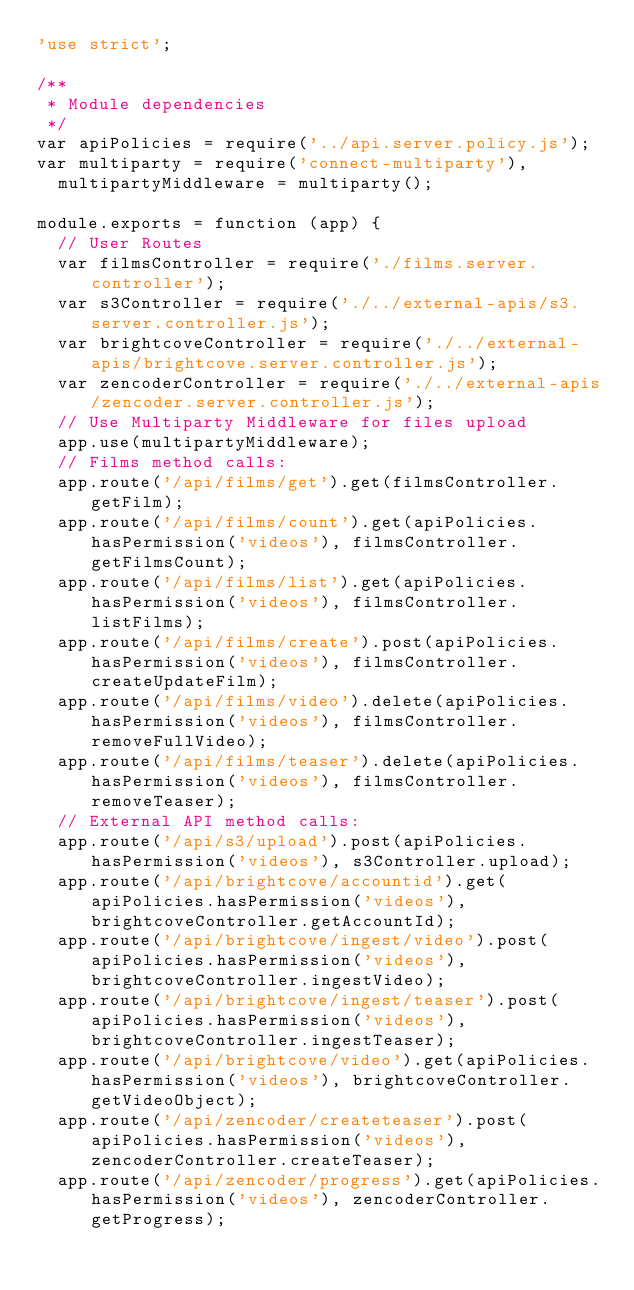<code> <loc_0><loc_0><loc_500><loc_500><_JavaScript_>'use strict';

/**
 * Module dependencies
 */
var apiPolicies = require('../api.server.policy.js');
var multiparty = require('connect-multiparty'),
  multipartyMiddleware = multiparty();

module.exports = function (app) {
  // User Routes
  var filmsController = require('./films.server.controller');
  var s3Controller = require('./../external-apis/s3.server.controller.js');
  var brightcoveController = require('./../external-apis/brightcove.server.controller.js');
  var zencoderController = require('./../external-apis/zencoder.server.controller.js');
  // Use Multiparty Middleware for files upload
  app.use(multipartyMiddleware);
  // Films method calls:
  app.route('/api/films/get').get(filmsController.getFilm);
  app.route('/api/films/count').get(apiPolicies.hasPermission('videos'), filmsController.getFilmsCount);
  app.route('/api/films/list').get(apiPolicies.hasPermission('videos'), filmsController.listFilms);
  app.route('/api/films/create').post(apiPolicies.hasPermission('videos'), filmsController.createUpdateFilm);
  app.route('/api/films/video').delete(apiPolicies.hasPermission('videos'), filmsController.removeFullVideo);
  app.route('/api/films/teaser').delete(apiPolicies.hasPermission('videos'), filmsController.removeTeaser);
  // External API method calls:
  app.route('/api/s3/upload').post(apiPolicies.hasPermission('videos'), s3Controller.upload);
  app.route('/api/brightcove/accountid').get(apiPolicies.hasPermission('videos'), brightcoveController.getAccountId);
  app.route('/api/brightcove/ingest/video').post(apiPolicies.hasPermission('videos'), brightcoveController.ingestVideo);
  app.route('/api/brightcove/ingest/teaser').post(apiPolicies.hasPermission('videos'), brightcoveController.ingestTeaser);
  app.route('/api/brightcove/video').get(apiPolicies.hasPermission('videos'), brightcoveController.getVideoObject);
  app.route('/api/zencoder/createteaser').post(apiPolicies.hasPermission('videos'), zencoderController.createTeaser);
  app.route('/api/zencoder/progress').get(apiPolicies.hasPermission('videos'), zencoderController.getProgress);</code> 